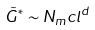<formula> <loc_0><loc_0><loc_500><loc_500>\tilde { G } ^ { * } \sim N _ { m } c l ^ { d }</formula> 